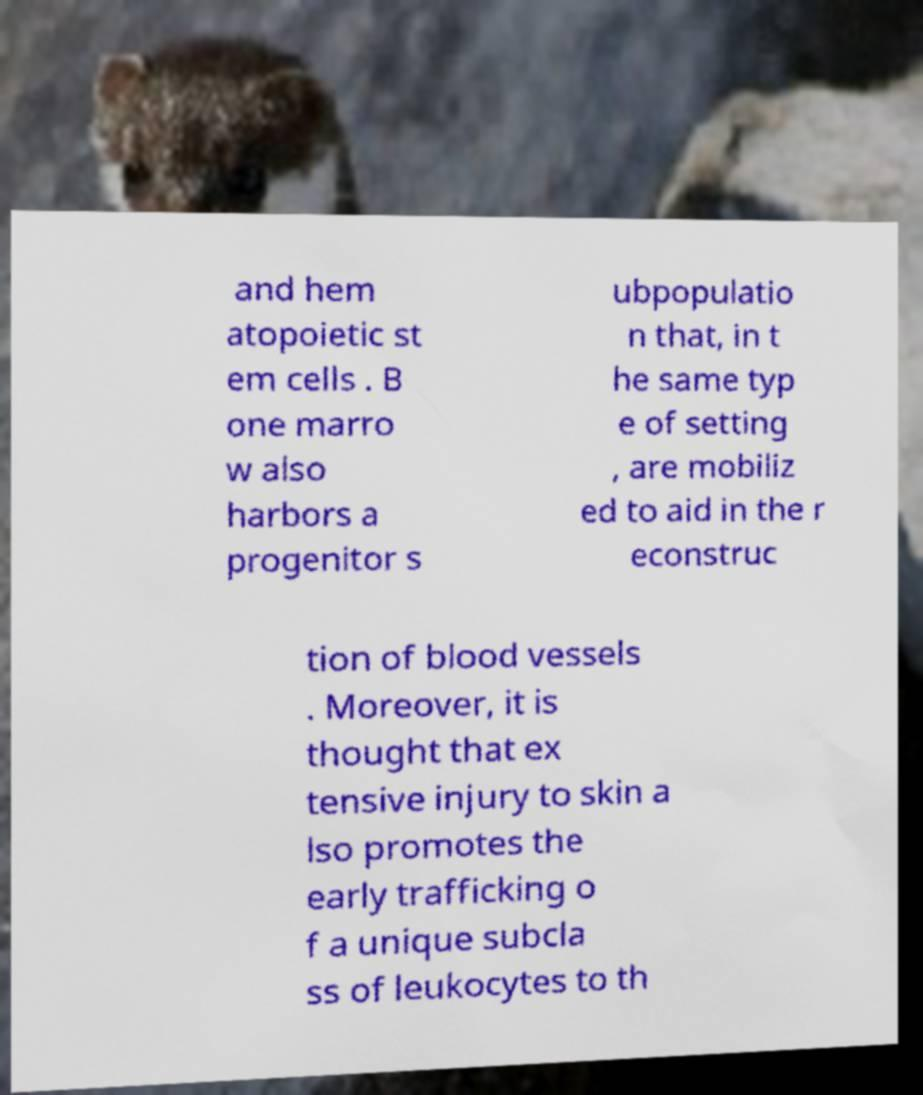Can you read and provide the text displayed in the image?This photo seems to have some interesting text. Can you extract and type it out for me? and hem atopoietic st em cells . B one marro w also harbors a progenitor s ubpopulatio n that, in t he same typ e of setting , are mobiliz ed to aid in the r econstruc tion of blood vessels . Moreover, it is thought that ex tensive injury to skin a lso promotes the early trafficking o f a unique subcla ss of leukocytes to th 